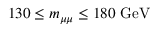<formula> <loc_0><loc_0><loc_500><loc_500>1 3 0 \leq { m _ { \mu \mu } } \leq 1 8 0 \ G e V</formula> 